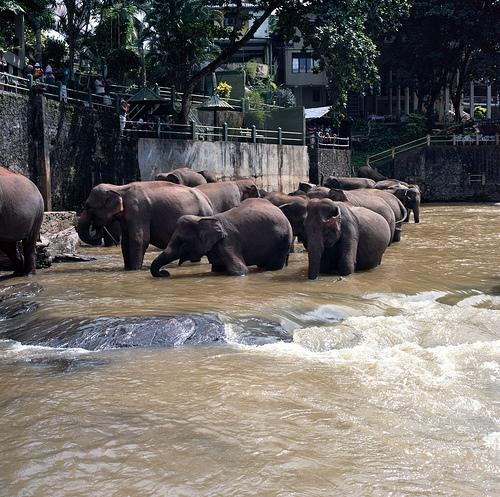Analyze the image sentiment, and describe the overall mood and tone. The image has a peaceful and natural tone, with people observing elephants interacting with their environment in a serene manner. What are the smaller details related to the elephants, such as body parts or actions, observed in the image? Elephant trunks, ears, eyes, open mouths, tails, legs, and rear ends are visible, with some interacting with the water or each other. What is the predominant element in the image? Elephants in the water, either drinking or otherwise interacting with the water. Describe the setting of the image, such as where the objects or animals are located. The setting is a watery environment, possibly a stream, with elephants in the water, green trees in the background, and people observing from above. Count the number of elephants present in the image and provide a brief description. There are several elephants (more than 5), mostly large and grey, in water, with some bending down or appearing to drink from the water. In simple terms, explain the human activity taking place in the image. People are standing up above, watching and looking down at the elephants in the water. Do you see a person swimming in water near the elephants? While there are several instances of people looking at the elephants, there is no mention of anyone swimming. Provide a poetic caption for the image. Serene water cradles wise giants, as curious eyes marvel from above, life interweaving gracefully. What type of fence can be found in the image? A small wooden fence Are there any dogs playing in the water? No, it's not mentioned in the image. What activity are the elephants engaged in? Drinking water What is the color of the overhang present in the image? Green Identify the location of the person wearing a blue shirt. Near the top-left corner of the image, among the group of people observing the elephants. List two body parts of the elephant that are specifically mentioned in the image data. Trunk and ear Which animal in the image has an open mouth? An elephant What can be inferred about the possible presence of restaurants or cafes in the image? There might be a nearby outdoor dining area, as evidenced by the presence of umbrellas, tables, and chairs. Create a story combining information from the image with additional elements. Once upon a time, in a lush forest, a group of people stumbled upon a magical stream teeming with gentle elephants. They marveled at their majestic wisdom, and their laughter echoed through the tranquil air, reverberating with the song of life. What event is occurring in the scene depicted in the image? Elephants drinking from a stream while being observed by people What is the dominating color of the railing in the image? Yellow Describe the dominant feature of the image in a single phrase. Elephants drinking in the water List all the objects and activities depicted in the image in a single sentence. Elephants in water, people watching, tree, umbrellas near table and chairs, person wearing blue shirt, and water pouring over rocks. Is there a red umbrella near the table and chairs? While there are umbrellas mentioned, they are not specified to be red or have any color mentioned. Which choices describe the main activity of the people in the image? A) Swimming B) Sunbathing C) Watching elephants D) Eating C) Watching elephants Can you find any text or characters in the image that can be recognized? No Can you see a blue elephant bending down in water? There is no blue elephant in the image; all elephants mentioned are either grey or large, and none are described as blue. Describe the relationship between the elephants and the people in the image. The people are observing the group of elephants in the water. Identify the position of the windows in the image. In the building behind the elephants What can be inferred about the habitat of the elephants in the image? The habitat contains water sources, rocks, trees, and is possibly close to human settlements. Can you find a group of pink elephants in the water? There are several instances of elephants in the water, but none of them are described as pink. 